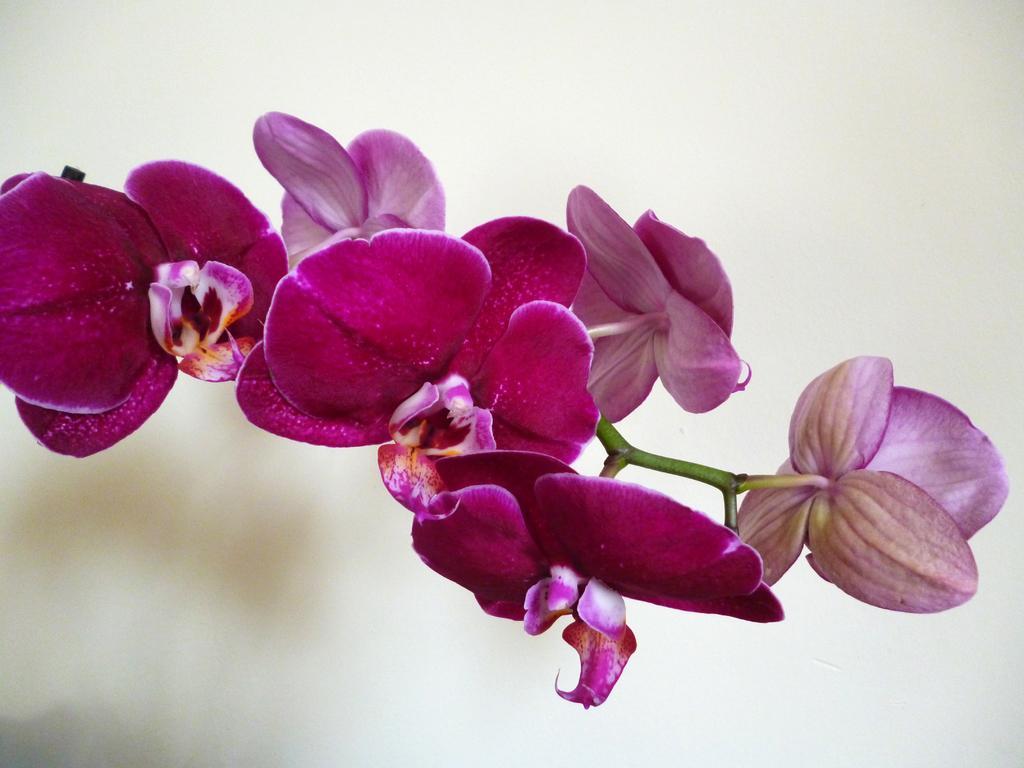How would you summarize this image in a sentence or two? In the center of this picture we can see the flowers and the stems. The background of the image is blurry. 